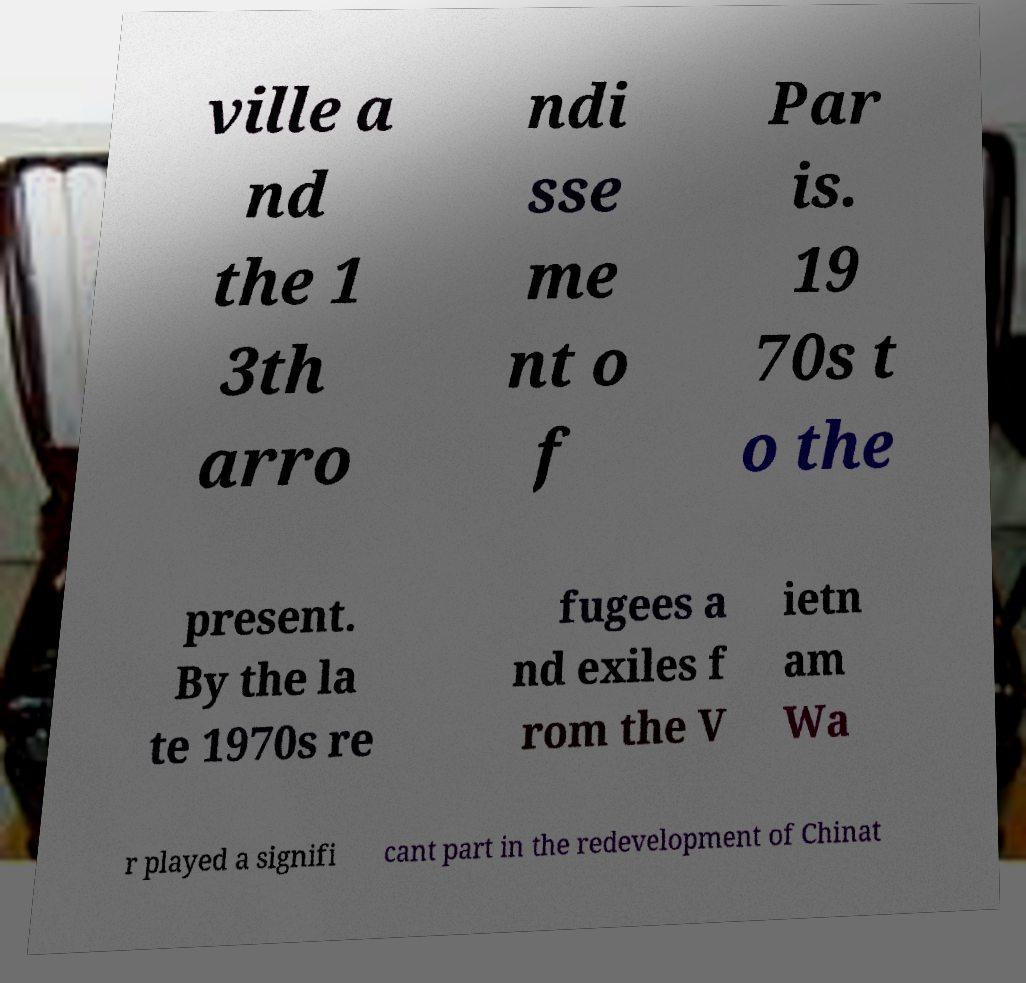Please read and relay the text visible in this image. What does it say? ville a nd the 1 3th arro ndi sse me nt o f Par is. 19 70s t o the present. By the la te 1970s re fugees a nd exiles f rom the V ietn am Wa r played a signifi cant part in the redevelopment of Chinat 